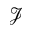Convert formula to latex. <formula><loc_0><loc_0><loc_500><loc_500>\mathcal { J }</formula> 